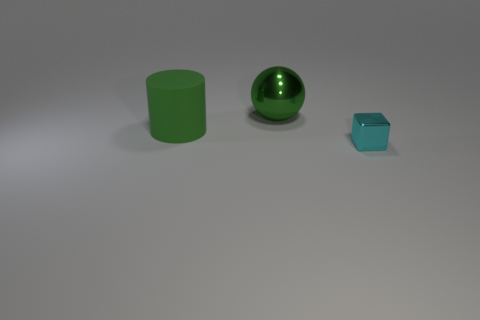The object that is the same color as the large metallic ball is what shape? cylinder 